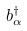Convert formula to latex. <formula><loc_0><loc_0><loc_500><loc_500>b _ { \alpha } ^ { \dagger }</formula> 